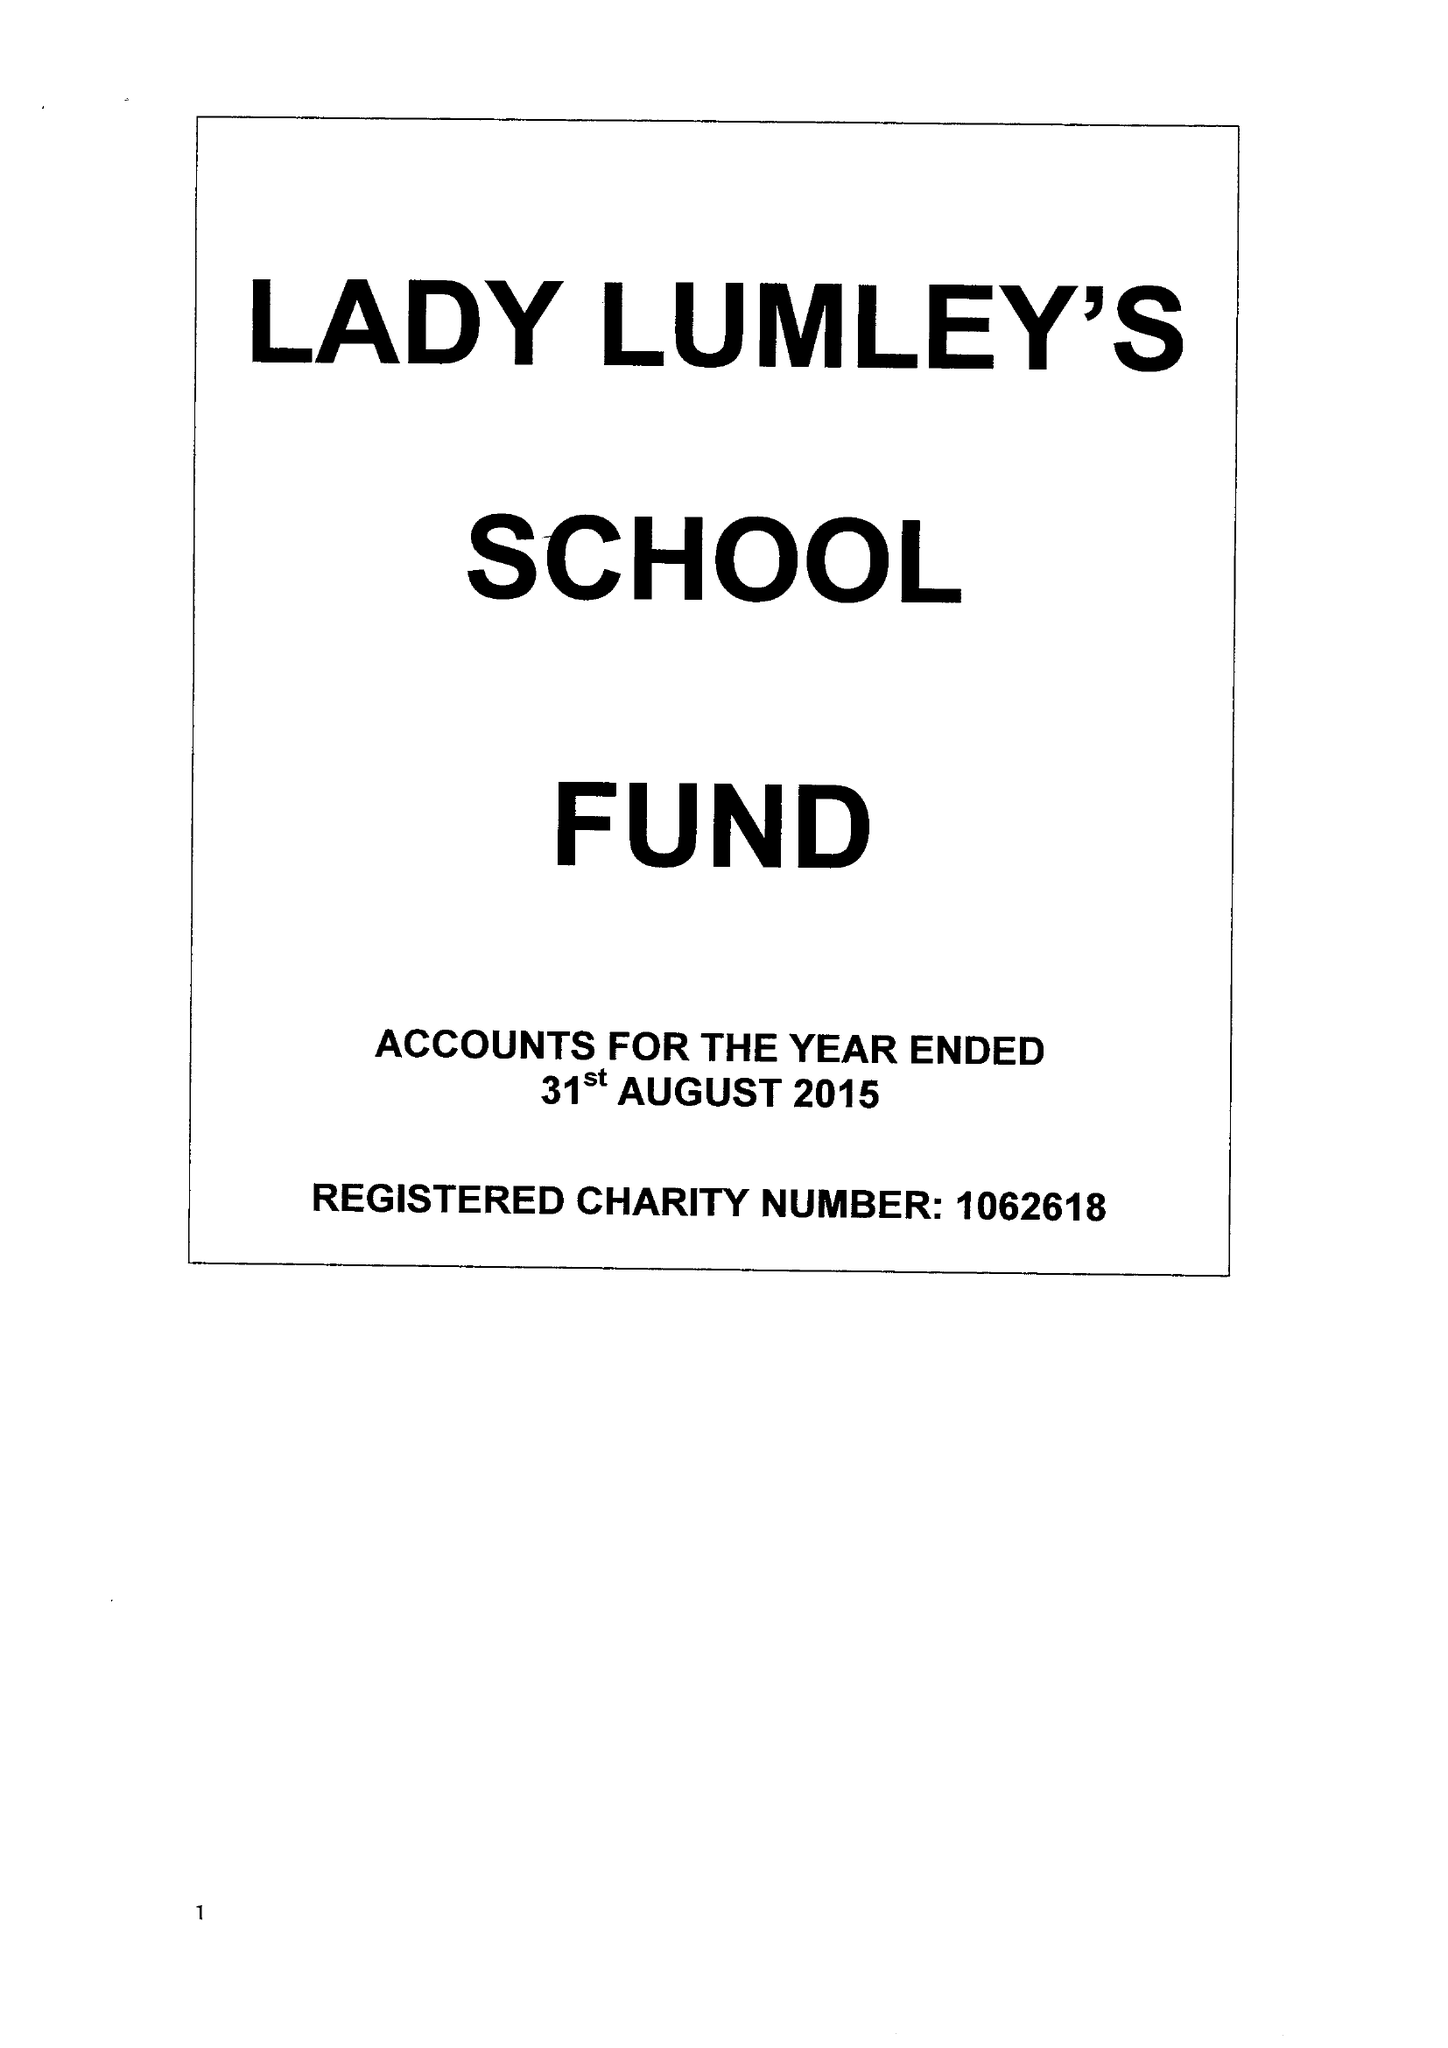What is the value for the income_annually_in_british_pounds?
Answer the question using a single word or phrase. 163653.00 